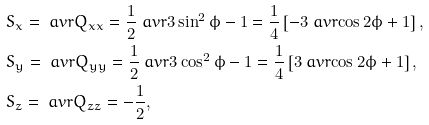Convert formula to latex. <formula><loc_0><loc_0><loc_500><loc_500>& S _ { x } = \ a v r { Q _ { x x } } = \frac { 1 } { 2 } \ a v r { 3 \sin ^ { 2 } \phi - 1 } = \frac { 1 } { 4 } \left [ - 3 \ a v r { \cos 2 \phi } + 1 \right ] , \\ & S _ { y } = \ a v r { Q _ { y y } } = \frac { 1 } { 2 } \ a v r { 3 \cos ^ { 2 } \phi - 1 } = \frac { 1 } { 4 } \left [ 3 \ a v r { \cos 2 \phi } + 1 \right ] , \\ & S _ { z } = \ a v r { Q _ { z z } } = - \frac { 1 } { 2 } ,</formula> 